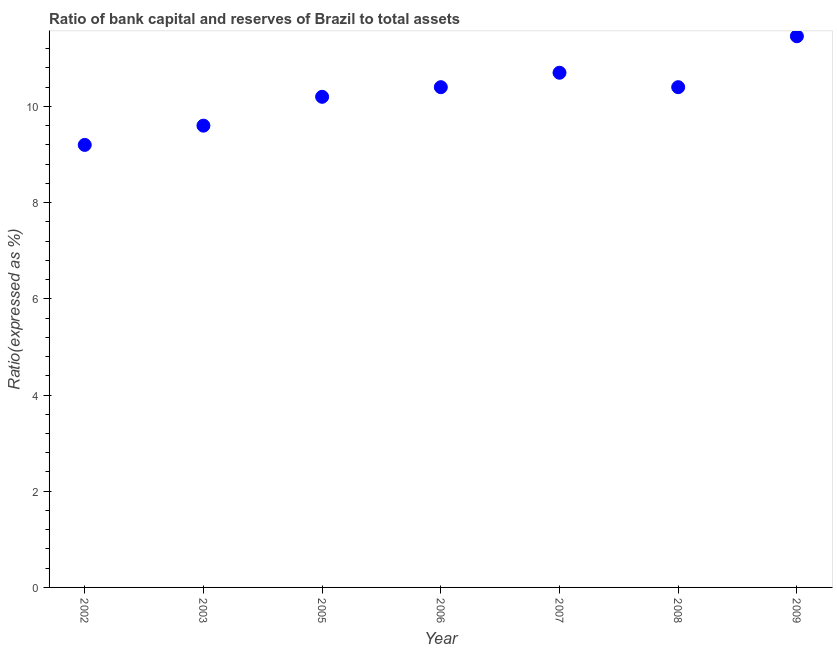What is the bank capital to assets ratio in 2009?
Make the answer very short. 11.46. Across all years, what is the maximum bank capital to assets ratio?
Provide a succinct answer. 11.46. Across all years, what is the minimum bank capital to assets ratio?
Provide a succinct answer. 9.2. In which year was the bank capital to assets ratio maximum?
Your answer should be compact. 2009. In which year was the bank capital to assets ratio minimum?
Provide a succinct answer. 2002. What is the sum of the bank capital to assets ratio?
Your answer should be compact. 71.96. What is the difference between the bank capital to assets ratio in 2002 and 2008?
Your answer should be compact. -1.2. What is the average bank capital to assets ratio per year?
Offer a very short reply. 10.28. What is the median bank capital to assets ratio?
Offer a terse response. 10.4. Do a majority of the years between 2006 and 2008 (inclusive) have bank capital to assets ratio greater than 3.6 %?
Give a very brief answer. Yes. What is the ratio of the bank capital to assets ratio in 2003 to that in 2006?
Offer a very short reply. 0.92. Is the difference between the bank capital to assets ratio in 2002 and 2005 greater than the difference between any two years?
Give a very brief answer. No. What is the difference between the highest and the second highest bank capital to assets ratio?
Your answer should be very brief. 0.76. What is the difference between the highest and the lowest bank capital to assets ratio?
Give a very brief answer. 2.26. How many dotlines are there?
Ensure brevity in your answer.  1. How many years are there in the graph?
Provide a short and direct response. 7. What is the difference between two consecutive major ticks on the Y-axis?
Ensure brevity in your answer.  2. Does the graph contain any zero values?
Provide a succinct answer. No. What is the title of the graph?
Give a very brief answer. Ratio of bank capital and reserves of Brazil to total assets. What is the label or title of the Y-axis?
Your response must be concise. Ratio(expressed as %). What is the Ratio(expressed as %) in 2002?
Keep it short and to the point. 9.2. What is the Ratio(expressed as %) in 2003?
Offer a very short reply. 9.6. What is the Ratio(expressed as %) in 2005?
Your answer should be compact. 10.2. What is the Ratio(expressed as %) in 2006?
Provide a succinct answer. 10.4. What is the Ratio(expressed as %) in 2007?
Your response must be concise. 10.7. What is the Ratio(expressed as %) in 2009?
Offer a very short reply. 11.46. What is the difference between the Ratio(expressed as %) in 2002 and 2005?
Offer a very short reply. -1. What is the difference between the Ratio(expressed as %) in 2002 and 2006?
Keep it short and to the point. -1.2. What is the difference between the Ratio(expressed as %) in 2002 and 2008?
Your response must be concise. -1.2. What is the difference between the Ratio(expressed as %) in 2002 and 2009?
Give a very brief answer. -2.26. What is the difference between the Ratio(expressed as %) in 2003 and 2005?
Keep it short and to the point. -0.6. What is the difference between the Ratio(expressed as %) in 2003 and 2006?
Offer a terse response. -0.8. What is the difference between the Ratio(expressed as %) in 2003 and 2009?
Your answer should be compact. -1.86. What is the difference between the Ratio(expressed as %) in 2005 and 2006?
Your answer should be very brief. -0.2. What is the difference between the Ratio(expressed as %) in 2005 and 2009?
Offer a terse response. -1.26. What is the difference between the Ratio(expressed as %) in 2006 and 2007?
Offer a very short reply. -0.3. What is the difference between the Ratio(expressed as %) in 2006 and 2008?
Offer a very short reply. 0. What is the difference between the Ratio(expressed as %) in 2006 and 2009?
Provide a succinct answer. -1.06. What is the difference between the Ratio(expressed as %) in 2007 and 2009?
Provide a short and direct response. -0.76. What is the difference between the Ratio(expressed as %) in 2008 and 2009?
Keep it short and to the point. -1.06. What is the ratio of the Ratio(expressed as %) in 2002 to that in 2003?
Keep it short and to the point. 0.96. What is the ratio of the Ratio(expressed as %) in 2002 to that in 2005?
Offer a very short reply. 0.9. What is the ratio of the Ratio(expressed as %) in 2002 to that in 2006?
Your answer should be compact. 0.89. What is the ratio of the Ratio(expressed as %) in 2002 to that in 2007?
Offer a terse response. 0.86. What is the ratio of the Ratio(expressed as %) in 2002 to that in 2008?
Ensure brevity in your answer.  0.89. What is the ratio of the Ratio(expressed as %) in 2002 to that in 2009?
Provide a short and direct response. 0.8. What is the ratio of the Ratio(expressed as %) in 2003 to that in 2005?
Offer a very short reply. 0.94. What is the ratio of the Ratio(expressed as %) in 2003 to that in 2006?
Offer a terse response. 0.92. What is the ratio of the Ratio(expressed as %) in 2003 to that in 2007?
Offer a terse response. 0.9. What is the ratio of the Ratio(expressed as %) in 2003 to that in 2008?
Provide a succinct answer. 0.92. What is the ratio of the Ratio(expressed as %) in 2003 to that in 2009?
Give a very brief answer. 0.84. What is the ratio of the Ratio(expressed as %) in 2005 to that in 2006?
Your answer should be very brief. 0.98. What is the ratio of the Ratio(expressed as %) in 2005 to that in 2007?
Provide a short and direct response. 0.95. What is the ratio of the Ratio(expressed as %) in 2005 to that in 2008?
Your response must be concise. 0.98. What is the ratio of the Ratio(expressed as %) in 2005 to that in 2009?
Your response must be concise. 0.89. What is the ratio of the Ratio(expressed as %) in 2006 to that in 2008?
Provide a short and direct response. 1. What is the ratio of the Ratio(expressed as %) in 2006 to that in 2009?
Make the answer very short. 0.91. What is the ratio of the Ratio(expressed as %) in 2007 to that in 2008?
Your response must be concise. 1.03. What is the ratio of the Ratio(expressed as %) in 2007 to that in 2009?
Your answer should be very brief. 0.93. What is the ratio of the Ratio(expressed as %) in 2008 to that in 2009?
Ensure brevity in your answer.  0.91. 